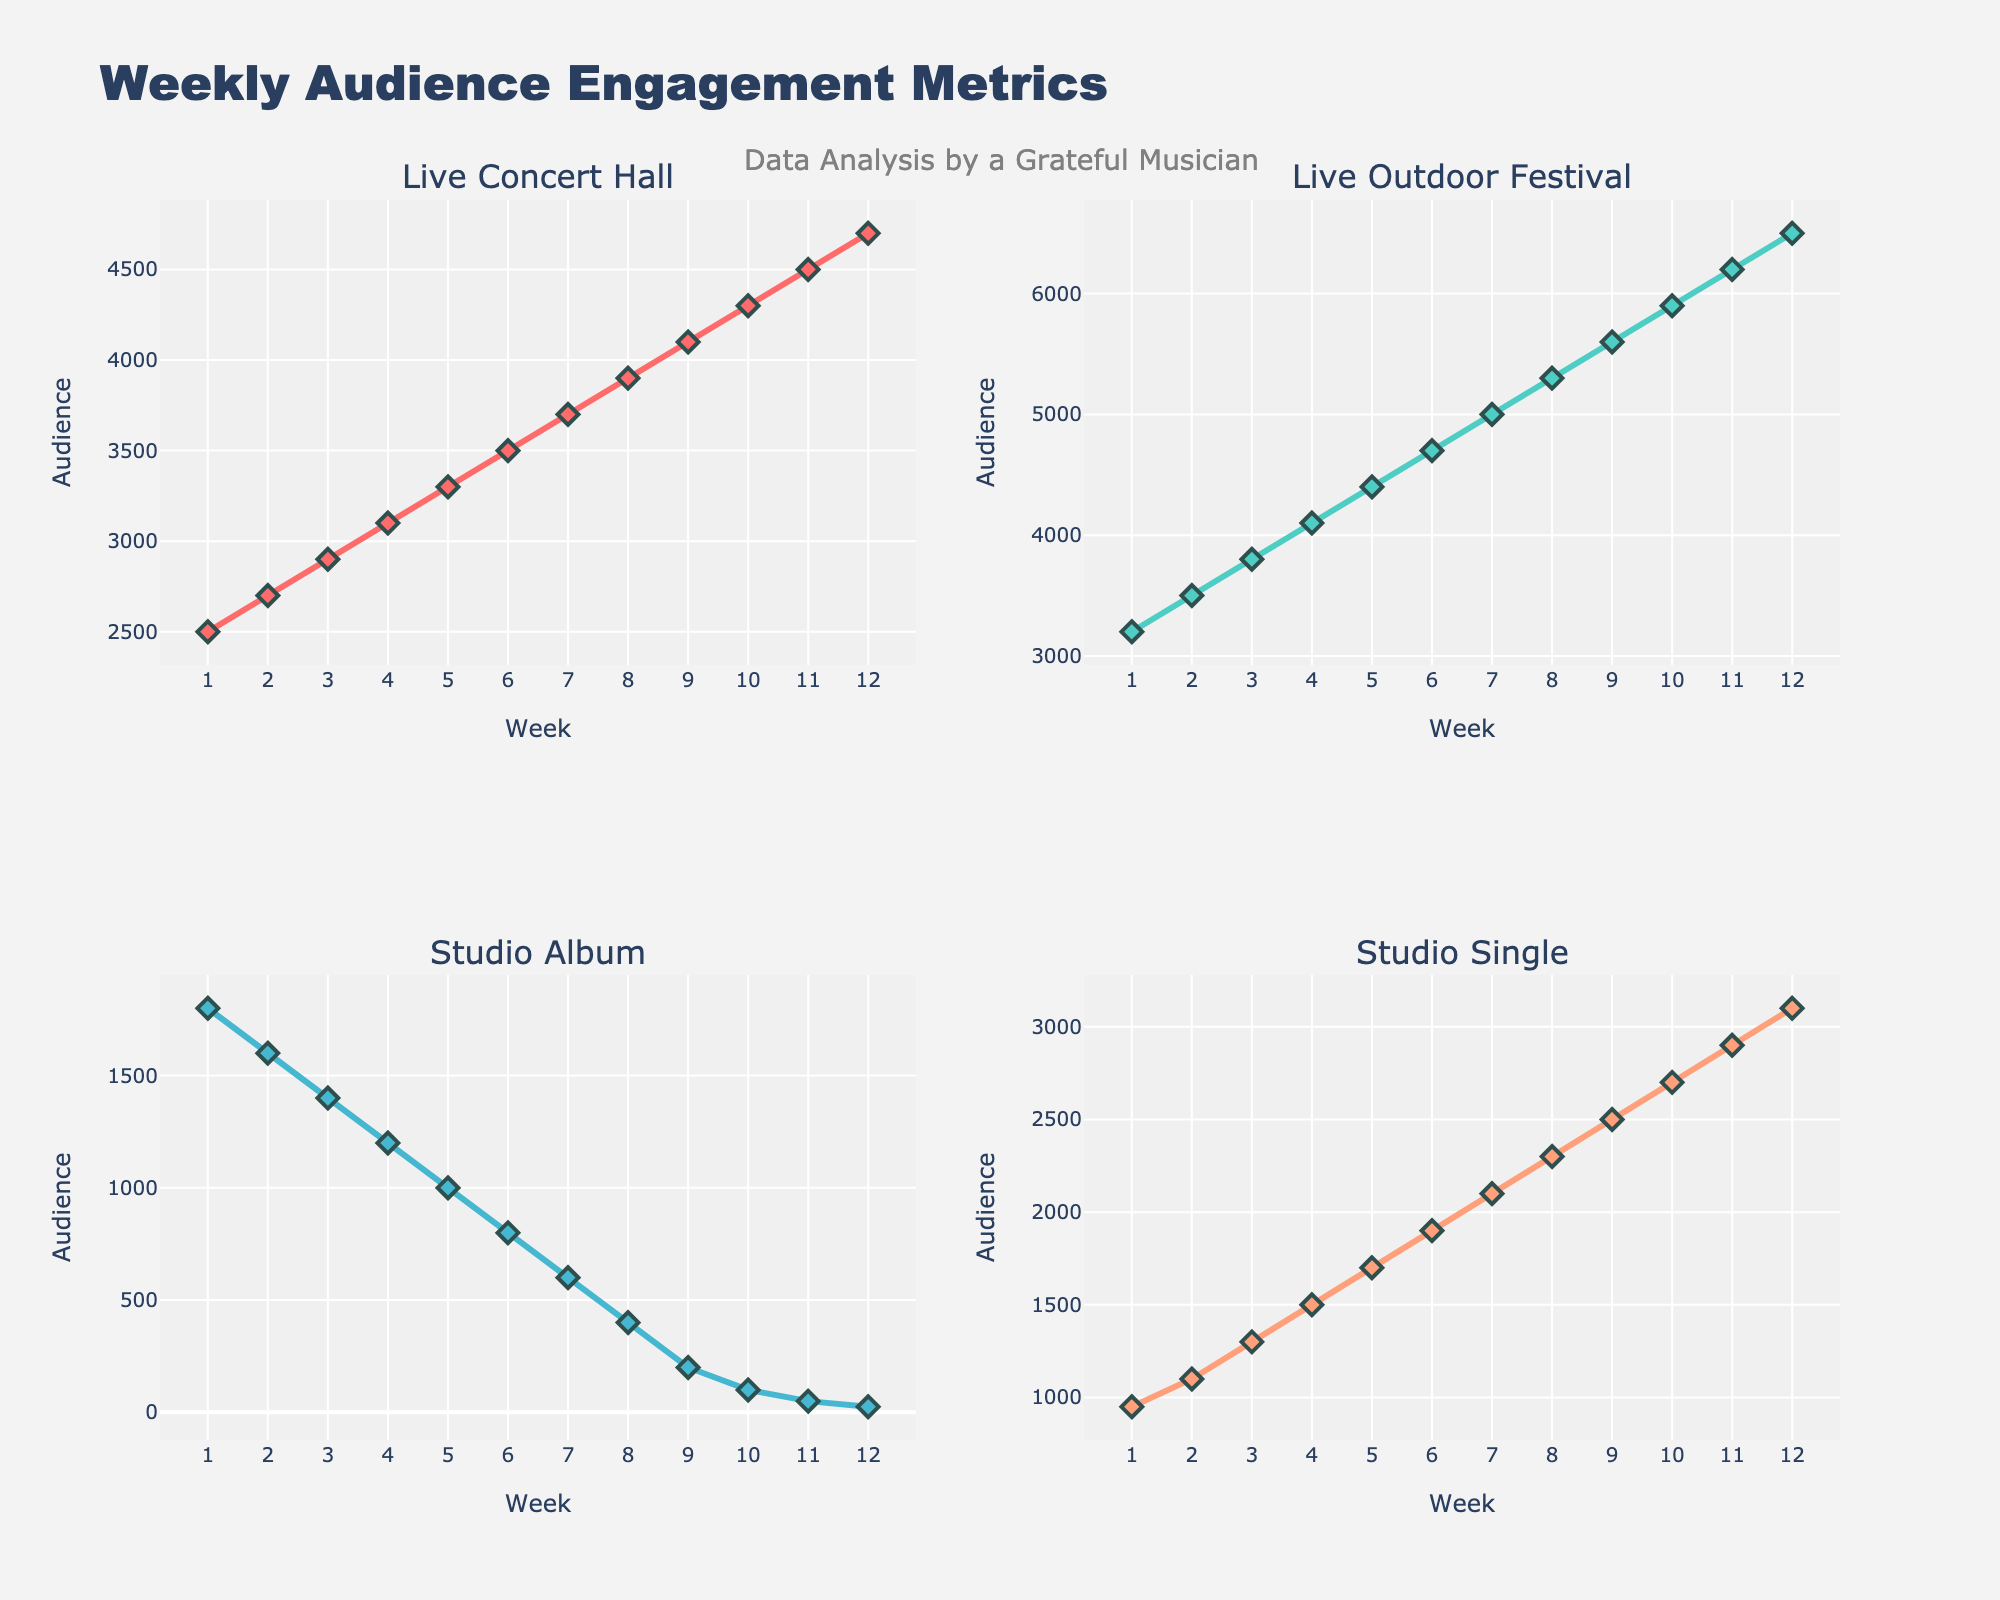What's the overall trend in audience engagement for live performances versus studio recordings over the weeks? The overall trend for live performances (both Concert Hall and Outdoor Festival) shows a steady increase in audience engagement each week. Conversely, audience engagement for studio recordings (Album and Single) shows a steady decline as weeks pass.
Answer: Increasing for live performances, decreasing for studio recordings Which has the highest audience engagement in week 6? In week 6, the Live Outdoor Festival has the highest audience engagement. We can observe this directly from the plot where the line for Live Outdoor Festival is above all others at week 6.
Answer: Live Outdoor Festival What is the approximate increase in audience engagement for Live Concert Hall from week 1 to week 12? From the plot, the audience engagement for Live Concert Hall starts at about 2500 in week 1 and rises to about 4700 in week 12. The increase is 4700 - 2500.
Answer: 2200 How does Studio Single's audience engagement in week 12 compare to its engagement in week 6? In week 12, Studio Single's audience engagement is about 3100, whereas in week 6 it is approximately 1900. The audience engagement for Studio Single increased by 3100 - 1900.
Answer: Increased by 1200 What week does Live Concert Hall see a greater audience engagement than Studio Single for the first time? By observing the plots of Live Concert Hall and Studio Single, we see that Live Concert Hall surpasses Studio Single's audience engagement for the first time around week 3.
Answer: Week 3 How does the slope of the line for Live Outdoor Festival compare to the slope of the line for Studio Album? The slope of the line for Live Outdoor Festival is always positive, indicating an increase in audience engagement. Conversely, the slope for Studio Album is negative, which shows a decrease. The positive slope for the Outdoor Festival is steeper than the negative slope for the Studio Album, meaning engagement increases faster in festivals than it decreases in albums.
Answer: Outdoor Festival slope is steeper and positive, Studio Album slope is negative In which weeks do Studio Single and Live Concert Hall have the same audience engagement levels? Observing the intersection points on the plot, we see that both Studio Single and Live Concert Hall lines intersect at approximately week 10.
Answer: Week 10 What is the average weekly increase in audience engagement for Live Outdoor Festival? The increase from week 1 to week 12 for Live Outdoor Festival is from approximately 3200 to 6500, resulting in an increase of 6500 - 3200 = 3300. Since this is over 12 weeks, the average weekly increase is 3300 / 12.
Answer: 275 Which type of performance had the highest audience engagement growth rate? Analyzing the lines, Live Outdoor Festival has the highest growth rate because its audience increases from 3200 in week 1 to 6500 in week 12, a significant increase rate over the concert season.
Answer: Live Outdoor Festival What happens to Studio Album's audience engagement from week 1 to week 12? Studio Album's audience engagement consistently decreases from week 1 to week 12. It starts at approximately 1800 in week 1 and drops down to about 25.
Answer: Decreases 